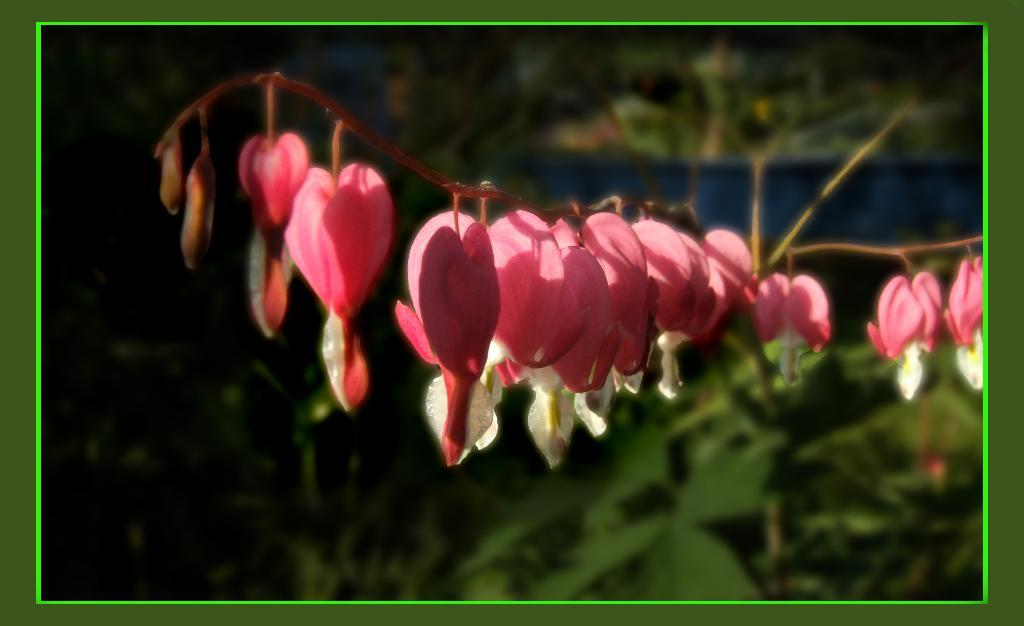What type of plant is in the image? There is a plant in the image with red color flowers. What color are the leaves of the plant? The leaves of the plant are not visible in the image, but there are green leaves in the background. What color is the border of the image? The border of the image is in green color. What type of prison can be seen in the image? There is no prison present in the image; it features a plant with red flowers and green leaves in the background. How does the rock contribute to the overall aesthetic of the image? There is no rock present in the image; it only contains a plant and green leaves in the background. 